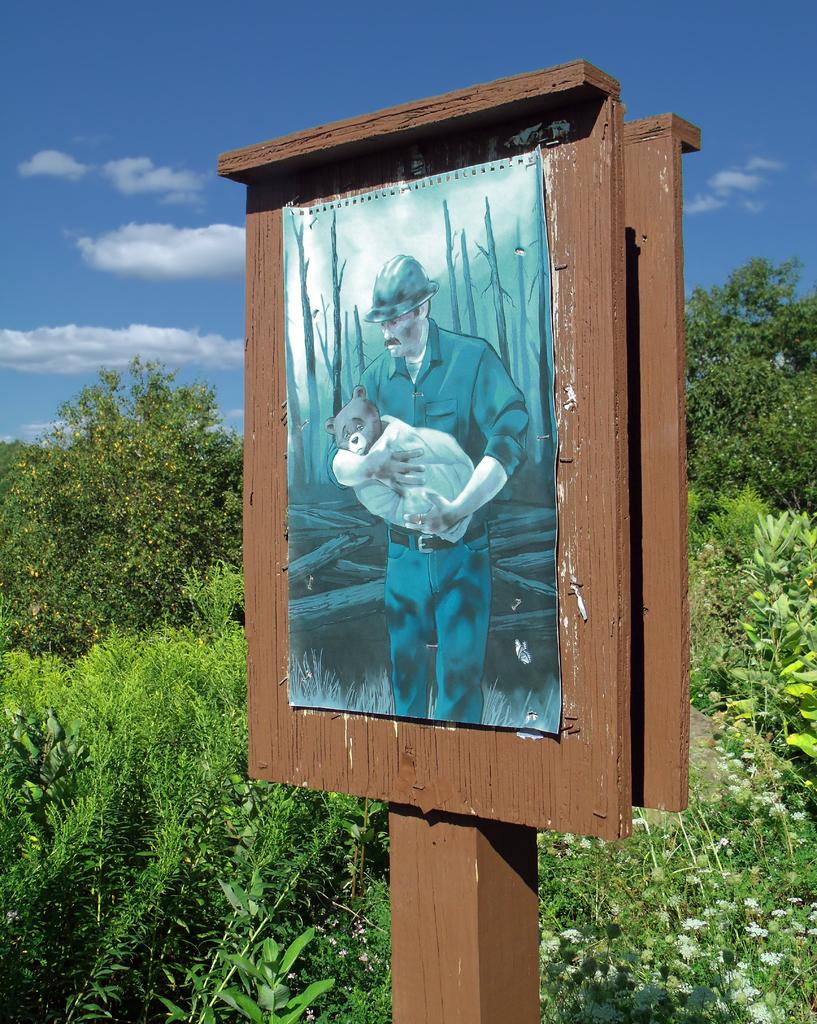What is the main subject of the image? The main subject of the image is a photo of a man. What is the man wearing in the image? The man is wearing a helmet in the image. What is the man doing with his hands in the image? The man is holding an animal with his hands in the image. What is the man and the animal standing on in the image? The man and the animal are on a board in the image. What can be seen in the background of the image? Trees and the sky are visible in the background of the image. What is the condition of the sky in the image? The sky has clouds in the image. How much honey is the man collecting from the kittens in the image? There are no kittens or honey present in the image. What type of connection is the man making with the animal in the image? The man is holding the animal with his hands, but there is no indication of a specific connection being made. 